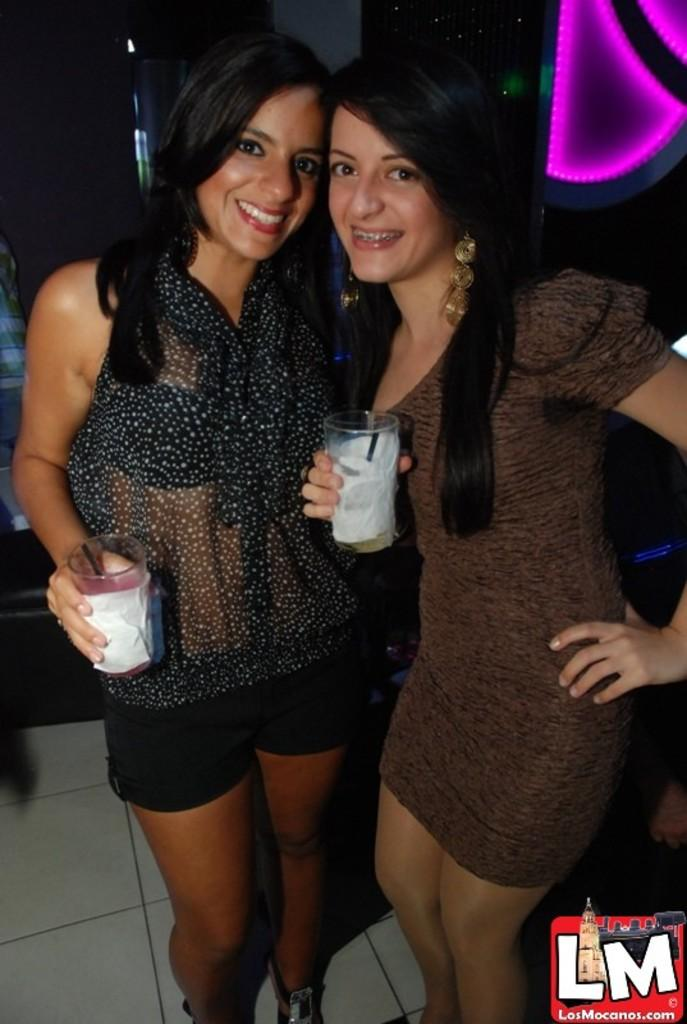How many women are present in the image? There are two women in the image. What are the women doing in the image? The women are standing in the image. What objects are the women holding in the image? The women are holding glasses in the image. What direction are the women facing in the image? The provided facts do not specify the direction the women are facing in the image. What sign can be seen on the wall behind the women in the image? There is no mention of a sign on the wall behind the women in the image. What type of gardening tool is visible in the image? There is no gardening tool, such as a spade, present in the image. 